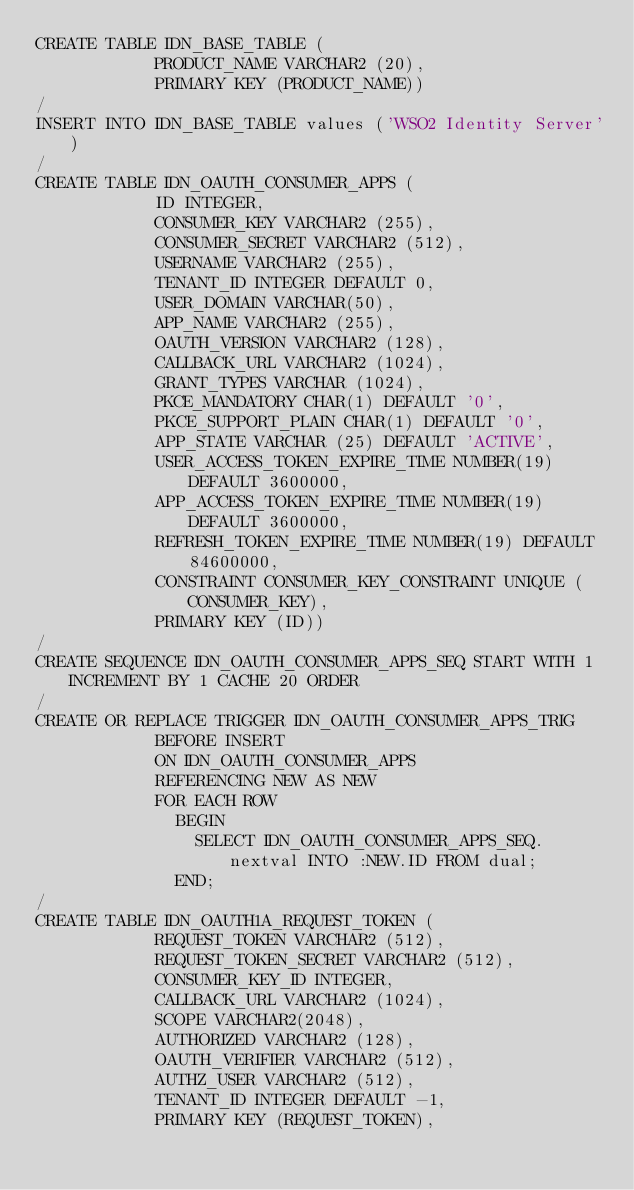<code> <loc_0><loc_0><loc_500><loc_500><_SQL_>CREATE TABLE IDN_BASE_TABLE (
            PRODUCT_NAME VARCHAR2 (20),
            PRIMARY KEY (PRODUCT_NAME))
/
INSERT INTO IDN_BASE_TABLE values ('WSO2 Identity Server')
/
CREATE TABLE IDN_OAUTH_CONSUMER_APPS (
            ID INTEGER,
            CONSUMER_KEY VARCHAR2 (255),
            CONSUMER_SECRET VARCHAR2 (512),
            USERNAME VARCHAR2 (255),
            TENANT_ID INTEGER DEFAULT 0,
            USER_DOMAIN VARCHAR(50),
            APP_NAME VARCHAR2 (255),
            OAUTH_VERSION VARCHAR2 (128),
            CALLBACK_URL VARCHAR2 (1024),
            GRANT_TYPES VARCHAR (1024),
            PKCE_MANDATORY CHAR(1) DEFAULT '0',
            PKCE_SUPPORT_PLAIN CHAR(1) DEFAULT '0',
            APP_STATE VARCHAR (25) DEFAULT 'ACTIVE',
            USER_ACCESS_TOKEN_EXPIRE_TIME NUMBER(19) DEFAULT 3600000,
            APP_ACCESS_TOKEN_EXPIRE_TIME NUMBER(19) DEFAULT 3600000,
            REFRESH_TOKEN_EXPIRE_TIME NUMBER(19) DEFAULT 84600000,
            CONSTRAINT CONSUMER_KEY_CONSTRAINT UNIQUE (CONSUMER_KEY),
            PRIMARY KEY (ID))
/
CREATE SEQUENCE IDN_OAUTH_CONSUMER_APPS_SEQ START WITH 1 INCREMENT BY 1 CACHE 20 ORDER
/
CREATE OR REPLACE TRIGGER IDN_OAUTH_CONSUMER_APPS_TRIG
            BEFORE INSERT
            ON IDN_OAUTH_CONSUMER_APPS
            REFERENCING NEW AS NEW
            FOR EACH ROW
              BEGIN
                SELECT IDN_OAUTH_CONSUMER_APPS_SEQ.nextval INTO :NEW.ID FROM dual;
              END;
/
CREATE TABLE IDN_OAUTH1A_REQUEST_TOKEN (
            REQUEST_TOKEN VARCHAR2 (512),
            REQUEST_TOKEN_SECRET VARCHAR2 (512),
            CONSUMER_KEY_ID INTEGER,
            CALLBACK_URL VARCHAR2 (1024),
            SCOPE VARCHAR2(2048),
            AUTHORIZED VARCHAR2 (128),
            OAUTH_VERIFIER VARCHAR2 (512),
            AUTHZ_USER VARCHAR2 (512),
            TENANT_ID INTEGER DEFAULT -1,
            PRIMARY KEY (REQUEST_TOKEN),</code> 